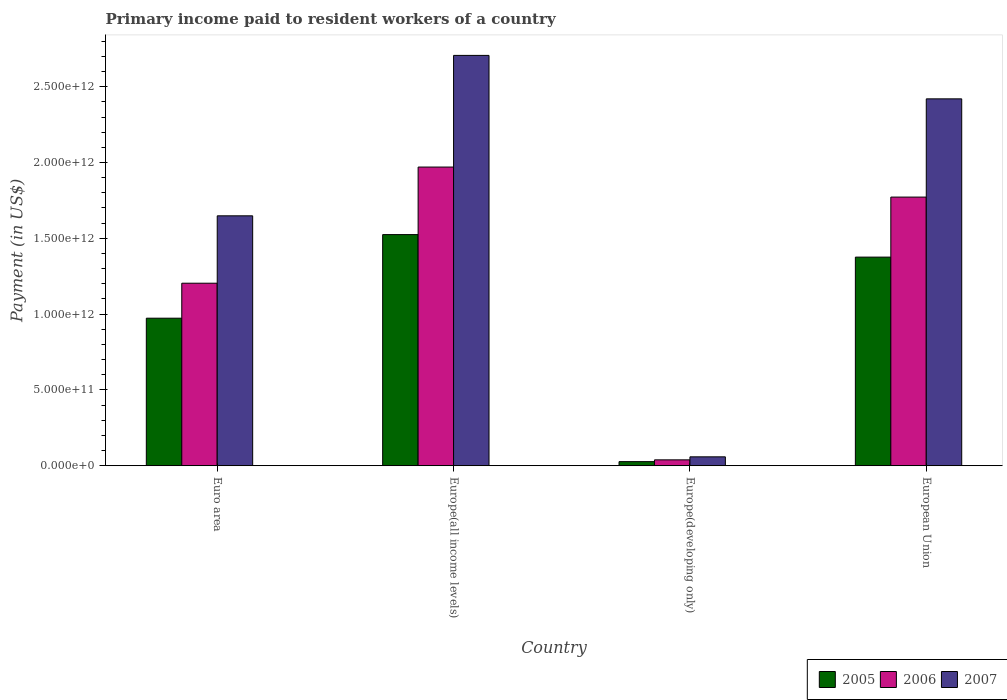How many different coloured bars are there?
Offer a terse response. 3. How many groups of bars are there?
Make the answer very short. 4. Are the number of bars per tick equal to the number of legend labels?
Make the answer very short. Yes. Are the number of bars on each tick of the X-axis equal?
Your response must be concise. Yes. How many bars are there on the 1st tick from the right?
Keep it short and to the point. 3. What is the label of the 3rd group of bars from the left?
Give a very brief answer. Europe(developing only). In how many cases, is the number of bars for a given country not equal to the number of legend labels?
Your response must be concise. 0. What is the amount paid to workers in 2005 in Euro area?
Provide a succinct answer. 9.73e+11. Across all countries, what is the maximum amount paid to workers in 2005?
Offer a very short reply. 1.52e+12. Across all countries, what is the minimum amount paid to workers in 2006?
Provide a succinct answer. 3.88e+1. In which country was the amount paid to workers in 2007 maximum?
Your response must be concise. Europe(all income levels). In which country was the amount paid to workers in 2006 minimum?
Your response must be concise. Europe(developing only). What is the total amount paid to workers in 2007 in the graph?
Provide a succinct answer. 6.83e+12. What is the difference between the amount paid to workers in 2007 in Euro area and that in Europe(developing only)?
Make the answer very short. 1.59e+12. What is the difference between the amount paid to workers in 2005 in Europe(all income levels) and the amount paid to workers in 2006 in European Union?
Your response must be concise. -2.47e+11. What is the average amount paid to workers in 2006 per country?
Your answer should be very brief. 1.25e+12. What is the difference between the amount paid to workers of/in 2007 and amount paid to workers of/in 2006 in Europe(developing only)?
Your answer should be compact. 1.99e+1. In how many countries, is the amount paid to workers in 2005 greater than 700000000000 US$?
Your response must be concise. 3. What is the ratio of the amount paid to workers in 2005 in Europe(developing only) to that in European Union?
Your answer should be very brief. 0.02. Is the difference between the amount paid to workers in 2007 in Europe(developing only) and European Union greater than the difference between the amount paid to workers in 2006 in Europe(developing only) and European Union?
Your response must be concise. No. What is the difference between the highest and the second highest amount paid to workers in 2006?
Make the answer very short. 5.68e+11. What is the difference between the highest and the lowest amount paid to workers in 2007?
Keep it short and to the point. 2.65e+12. In how many countries, is the amount paid to workers in 2005 greater than the average amount paid to workers in 2005 taken over all countries?
Keep it short and to the point. 2. Is the sum of the amount paid to workers in 2006 in Euro area and Europe(developing only) greater than the maximum amount paid to workers in 2005 across all countries?
Ensure brevity in your answer.  No. What does the 1st bar from the right in Europe(all income levels) represents?
Your answer should be very brief. 2007. Is it the case that in every country, the sum of the amount paid to workers in 2005 and amount paid to workers in 2007 is greater than the amount paid to workers in 2006?
Give a very brief answer. Yes. How many bars are there?
Offer a terse response. 12. Are all the bars in the graph horizontal?
Your answer should be very brief. No. How many countries are there in the graph?
Keep it short and to the point. 4. What is the difference between two consecutive major ticks on the Y-axis?
Your answer should be compact. 5.00e+11. Are the values on the major ticks of Y-axis written in scientific E-notation?
Offer a very short reply. Yes. How many legend labels are there?
Make the answer very short. 3. How are the legend labels stacked?
Your response must be concise. Horizontal. What is the title of the graph?
Offer a terse response. Primary income paid to resident workers of a country. Does "1997" appear as one of the legend labels in the graph?
Keep it short and to the point. No. What is the label or title of the X-axis?
Provide a short and direct response. Country. What is the label or title of the Y-axis?
Keep it short and to the point. Payment (in US$). What is the Payment (in US$) in 2005 in Euro area?
Give a very brief answer. 9.73e+11. What is the Payment (in US$) in 2006 in Euro area?
Provide a short and direct response. 1.20e+12. What is the Payment (in US$) of 2007 in Euro area?
Offer a terse response. 1.65e+12. What is the Payment (in US$) of 2005 in Europe(all income levels)?
Make the answer very short. 1.52e+12. What is the Payment (in US$) of 2006 in Europe(all income levels)?
Provide a short and direct response. 1.97e+12. What is the Payment (in US$) of 2007 in Europe(all income levels)?
Your answer should be compact. 2.71e+12. What is the Payment (in US$) in 2005 in Europe(developing only)?
Provide a succinct answer. 2.70e+1. What is the Payment (in US$) of 2006 in Europe(developing only)?
Offer a very short reply. 3.88e+1. What is the Payment (in US$) in 2007 in Europe(developing only)?
Provide a short and direct response. 5.87e+1. What is the Payment (in US$) in 2005 in European Union?
Ensure brevity in your answer.  1.38e+12. What is the Payment (in US$) in 2006 in European Union?
Your answer should be very brief. 1.77e+12. What is the Payment (in US$) in 2007 in European Union?
Your answer should be compact. 2.42e+12. Across all countries, what is the maximum Payment (in US$) of 2005?
Offer a terse response. 1.52e+12. Across all countries, what is the maximum Payment (in US$) of 2006?
Offer a terse response. 1.97e+12. Across all countries, what is the maximum Payment (in US$) in 2007?
Offer a very short reply. 2.71e+12. Across all countries, what is the minimum Payment (in US$) of 2005?
Your answer should be compact. 2.70e+1. Across all countries, what is the minimum Payment (in US$) in 2006?
Provide a succinct answer. 3.88e+1. Across all countries, what is the minimum Payment (in US$) of 2007?
Give a very brief answer. 5.87e+1. What is the total Payment (in US$) of 2005 in the graph?
Provide a succinct answer. 3.90e+12. What is the total Payment (in US$) of 2006 in the graph?
Offer a terse response. 4.98e+12. What is the total Payment (in US$) in 2007 in the graph?
Offer a terse response. 6.83e+12. What is the difference between the Payment (in US$) of 2005 in Euro area and that in Europe(all income levels)?
Provide a succinct answer. -5.51e+11. What is the difference between the Payment (in US$) in 2006 in Euro area and that in Europe(all income levels)?
Your response must be concise. -7.66e+11. What is the difference between the Payment (in US$) of 2007 in Euro area and that in Europe(all income levels)?
Ensure brevity in your answer.  -1.06e+12. What is the difference between the Payment (in US$) in 2005 in Euro area and that in Europe(developing only)?
Give a very brief answer. 9.46e+11. What is the difference between the Payment (in US$) in 2006 in Euro area and that in Europe(developing only)?
Offer a terse response. 1.17e+12. What is the difference between the Payment (in US$) of 2007 in Euro area and that in Europe(developing only)?
Your response must be concise. 1.59e+12. What is the difference between the Payment (in US$) of 2005 in Euro area and that in European Union?
Ensure brevity in your answer.  -4.03e+11. What is the difference between the Payment (in US$) of 2006 in Euro area and that in European Union?
Give a very brief answer. -5.68e+11. What is the difference between the Payment (in US$) in 2007 in Euro area and that in European Union?
Offer a terse response. -7.71e+11. What is the difference between the Payment (in US$) in 2005 in Europe(all income levels) and that in Europe(developing only)?
Provide a short and direct response. 1.50e+12. What is the difference between the Payment (in US$) of 2006 in Europe(all income levels) and that in Europe(developing only)?
Ensure brevity in your answer.  1.93e+12. What is the difference between the Payment (in US$) in 2007 in Europe(all income levels) and that in Europe(developing only)?
Give a very brief answer. 2.65e+12. What is the difference between the Payment (in US$) of 2005 in Europe(all income levels) and that in European Union?
Your answer should be compact. 1.49e+11. What is the difference between the Payment (in US$) of 2006 in Europe(all income levels) and that in European Union?
Your response must be concise. 1.98e+11. What is the difference between the Payment (in US$) in 2007 in Europe(all income levels) and that in European Union?
Provide a short and direct response. 2.87e+11. What is the difference between the Payment (in US$) in 2005 in Europe(developing only) and that in European Union?
Give a very brief answer. -1.35e+12. What is the difference between the Payment (in US$) of 2006 in Europe(developing only) and that in European Union?
Keep it short and to the point. -1.73e+12. What is the difference between the Payment (in US$) in 2007 in Europe(developing only) and that in European Union?
Provide a short and direct response. -2.36e+12. What is the difference between the Payment (in US$) in 2005 in Euro area and the Payment (in US$) in 2006 in Europe(all income levels)?
Provide a succinct answer. -9.97e+11. What is the difference between the Payment (in US$) of 2005 in Euro area and the Payment (in US$) of 2007 in Europe(all income levels)?
Ensure brevity in your answer.  -1.73e+12. What is the difference between the Payment (in US$) of 2006 in Euro area and the Payment (in US$) of 2007 in Europe(all income levels)?
Make the answer very short. -1.50e+12. What is the difference between the Payment (in US$) in 2005 in Euro area and the Payment (in US$) in 2006 in Europe(developing only)?
Your answer should be very brief. 9.34e+11. What is the difference between the Payment (in US$) of 2005 in Euro area and the Payment (in US$) of 2007 in Europe(developing only)?
Offer a terse response. 9.14e+11. What is the difference between the Payment (in US$) in 2006 in Euro area and the Payment (in US$) in 2007 in Europe(developing only)?
Offer a terse response. 1.15e+12. What is the difference between the Payment (in US$) in 2005 in Euro area and the Payment (in US$) in 2006 in European Union?
Your response must be concise. -7.99e+11. What is the difference between the Payment (in US$) of 2005 in Euro area and the Payment (in US$) of 2007 in European Union?
Your answer should be very brief. -1.45e+12. What is the difference between the Payment (in US$) of 2006 in Euro area and the Payment (in US$) of 2007 in European Union?
Offer a very short reply. -1.22e+12. What is the difference between the Payment (in US$) in 2005 in Europe(all income levels) and the Payment (in US$) in 2006 in Europe(developing only)?
Your answer should be very brief. 1.49e+12. What is the difference between the Payment (in US$) in 2005 in Europe(all income levels) and the Payment (in US$) in 2007 in Europe(developing only)?
Give a very brief answer. 1.47e+12. What is the difference between the Payment (in US$) in 2006 in Europe(all income levels) and the Payment (in US$) in 2007 in Europe(developing only)?
Provide a short and direct response. 1.91e+12. What is the difference between the Payment (in US$) of 2005 in Europe(all income levels) and the Payment (in US$) of 2006 in European Union?
Ensure brevity in your answer.  -2.47e+11. What is the difference between the Payment (in US$) in 2005 in Europe(all income levels) and the Payment (in US$) in 2007 in European Union?
Ensure brevity in your answer.  -8.95e+11. What is the difference between the Payment (in US$) of 2006 in Europe(all income levels) and the Payment (in US$) of 2007 in European Union?
Keep it short and to the point. -4.50e+11. What is the difference between the Payment (in US$) in 2005 in Europe(developing only) and the Payment (in US$) in 2006 in European Union?
Make the answer very short. -1.74e+12. What is the difference between the Payment (in US$) of 2005 in Europe(developing only) and the Payment (in US$) of 2007 in European Union?
Provide a succinct answer. -2.39e+12. What is the difference between the Payment (in US$) in 2006 in Europe(developing only) and the Payment (in US$) in 2007 in European Union?
Make the answer very short. -2.38e+12. What is the average Payment (in US$) in 2005 per country?
Provide a short and direct response. 9.75e+11. What is the average Payment (in US$) in 2006 per country?
Provide a succinct answer. 1.25e+12. What is the average Payment (in US$) in 2007 per country?
Your answer should be compact. 1.71e+12. What is the difference between the Payment (in US$) in 2005 and Payment (in US$) in 2006 in Euro area?
Provide a short and direct response. -2.31e+11. What is the difference between the Payment (in US$) in 2005 and Payment (in US$) in 2007 in Euro area?
Your answer should be compact. -6.75e+11. What is the difference between the Payment (in US$) in 2006 and Payment (in US$) in 2007 in Euro area?
Your response must be concise. -4.44e+11. What is the difference between the Payment (in US$) of 2005 and Payment (in US$) of 2006 in Europe(all income levels)?
Give a very brief answer. -4.45e+11. What is the difference between the Payment (in US$) of 2005 and Payment (in US$) of 2007 in Europe(all income levels)?
Keep it short and to the point. -1.18e+12. What is the difference between the Payment (in US$) in 2006 and Payment (in US$) in 2007 in Europe(all income levels)?
Offer a terse response. -7.37e+11. What is the difference between the Payment (in US$) of 2005 and Payment (in US$) of 2006 in Europe(developing only)?
Provide a short and direct response. -1.18e+1. What is the difference between the Payment (in US$) of 2005 and Payment (in US$) of 2007 in Europe(developing only)?
Make the answer very short. -3.17e+1. What is the difference between the Payment (in US$) in 2006 and Payment (in US$) in 2007 in Europe(developing only)?
Ensure brevity in your answer.  -1.99e+1. What is the difference between the Payment (in US$) in 2005 and Payment (in US$) in 2006 in European Union?
Provide a succinct answer. -3.96e+11. What is the difference between the Payment (in US$) of 2005 and Payment (in US$) of 2007 in European Union?
Your response must be concise. -1.04e+12. What is the difference between the Payment (in US$) of 2006 and Payment (in US$) of 2007 in European Union?
Give a very brief answer. -6.48e+11. What is the ratio of the Payment (in US$) of 2005 in Euro area to that in Europe(all income levels)?
Offer a terse response. 0.64. What is the ratio of the Payment (in US$) in 2006 in Euro area to that in Europe(all income levels)?
Give a very brief answer. 0.61. What is the ratio of the Payment (in US$) of 2007 in Euro area to that in Europe(all income levels)?
Your answer should be very brief. 0.61. What is the ratio of the Payment (in US$) of 2005 in Euro area to that in Europe(developing only)?
Provide a short and direct response. 36.08. What is the ratio of the Payment (in US$) of 2006 in Euro area to that in Europe(developing only)?
Offer a terse response. 31.05. What is the ratio of the Payment (in US$) in 2007 in Euro area to that in Europe(developing only)?
Your response must be concise. 28.08. What is the ratio of the Payment (in US$) in 2005 in Euro area to that in European Union?
Your answer should be compact. 0.71. What is the ratio of the Payment (in US$) in 2006 in Euro area to that in European Union?
Provide a succinct answer. 0.68. What is the ratio of the Payment (in US$) of 2007 in Euro area to that in European Union?
Your answer should be compact. 0.68. What is the ratio of the Payment (in US$) of 2005 in Europe(all income levels) to that in Europe(developing only)?
Your answer should be compact. 56.52. What is the ratio of the Payment (in US$) of 2006 in Europe(all income levels) to that in Europe(developing only)?
Provide a succinct answer. 50.81. What is the ratio of the Payment (in US$) of 2007 in Europe(all income levels) to that in Europe(developing only)?
Your response must be concise. 46.11. What is the ratio of the Payment (in US$) of 2005 in Europe(all income levels) to that in European Union?
Provide a short and direct response. 1.11. What is the ratio of the Payment (in US$) of 2006 in Europe(all income levels) to that in European Union?
Make the answer very short. 1.11. What is the ratio of the Payment (in US$) in 2007 in Europe(all income levels) to that in European Union?
Provide a short and direct response. 1.12. What is the ratio of the Payment (in US$) in 2005 in Europe(developing only) to that in European Union?
Provide a short and direct response. 0.02. What is the ratio of the Payment (in US$) in 2006 in Europe(developing only) to that in European Union?
Provide a succinct answer. 0.02. What is the ratio of the Payment (in US$) in 2007 in Europe(developing only) to that in European Union?
Your answer should be compact. 0.02. What is the difference between the highest and the second highest Payment (in US$) of 2005?
Provide a succinct answer. 1.49e+11. What is the difference between the highest and the second highest Payment (in US$) of 2006?
Keep it short and to the point. 1.98e+11. What is the difference between the highest and the second highest Payment (in US$) of 2007?
Your response must be concise. 2.87e+11. What is the difference between the highest and the lowest Payment (in US$) in 2005?
Your answer should be compact. 1.50e+12. What is the difference between the highest and the lowest Payment (in US$) of 2006?
Offer a terse response. 1.93e+12. What is the difference between the highest and the lowest Payment (in US$) in 2007?
Offer a terse response. 2.65e+12. 